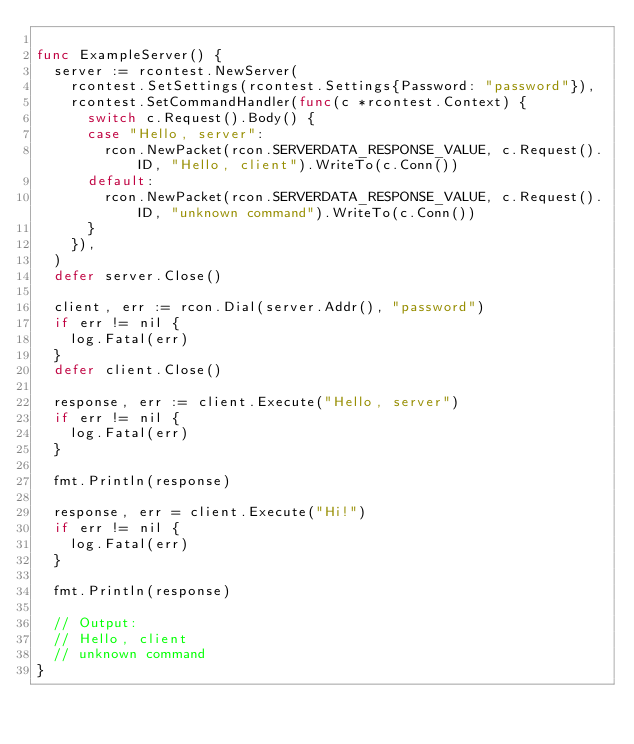<code> <loc_0><loc_0><loc_500><loc_500><_Go_>
func ExampleServer() {
	server := rcontest.NewServer(
		rcontest.SetSettings(rcontest.Settings{Password: "password"}),
		rcontest.SetCommandHandler(func(c *rcontest.Context) {
			switch c.Request().Body() {
			case "Hello, server":
				rcon.NewPacket(rcon.SERVERDATA_RESPONSE_VALUE, c.Request().ID, "Hello, client").WriteTo(c.Conn())
			default:
				rcon.NewPacket(rcon.SERVERDATA_RESPONSE_VALUE, c.Request().ID, "unknown command").WriteTo(c.Conn())
			}
		}),
	)
	defer server.Close()

	client, err := rcon.Dial(server.Addr(), "password")
	if err != nil {
		log.Fatal(err)
	}
	defer client.Close()

	response, err := client.Execute("Hello, server")
	if err != nil {
		log.Fatal(err)
	}

	fmt.Println(response)

	response, err = client.Execute("Hi!")
	if err != nil {
		log.Fatal(err)
	}

	fmt.Println(response)

	// Output:
	// Hello, client
	// unknown command
}
</code> 